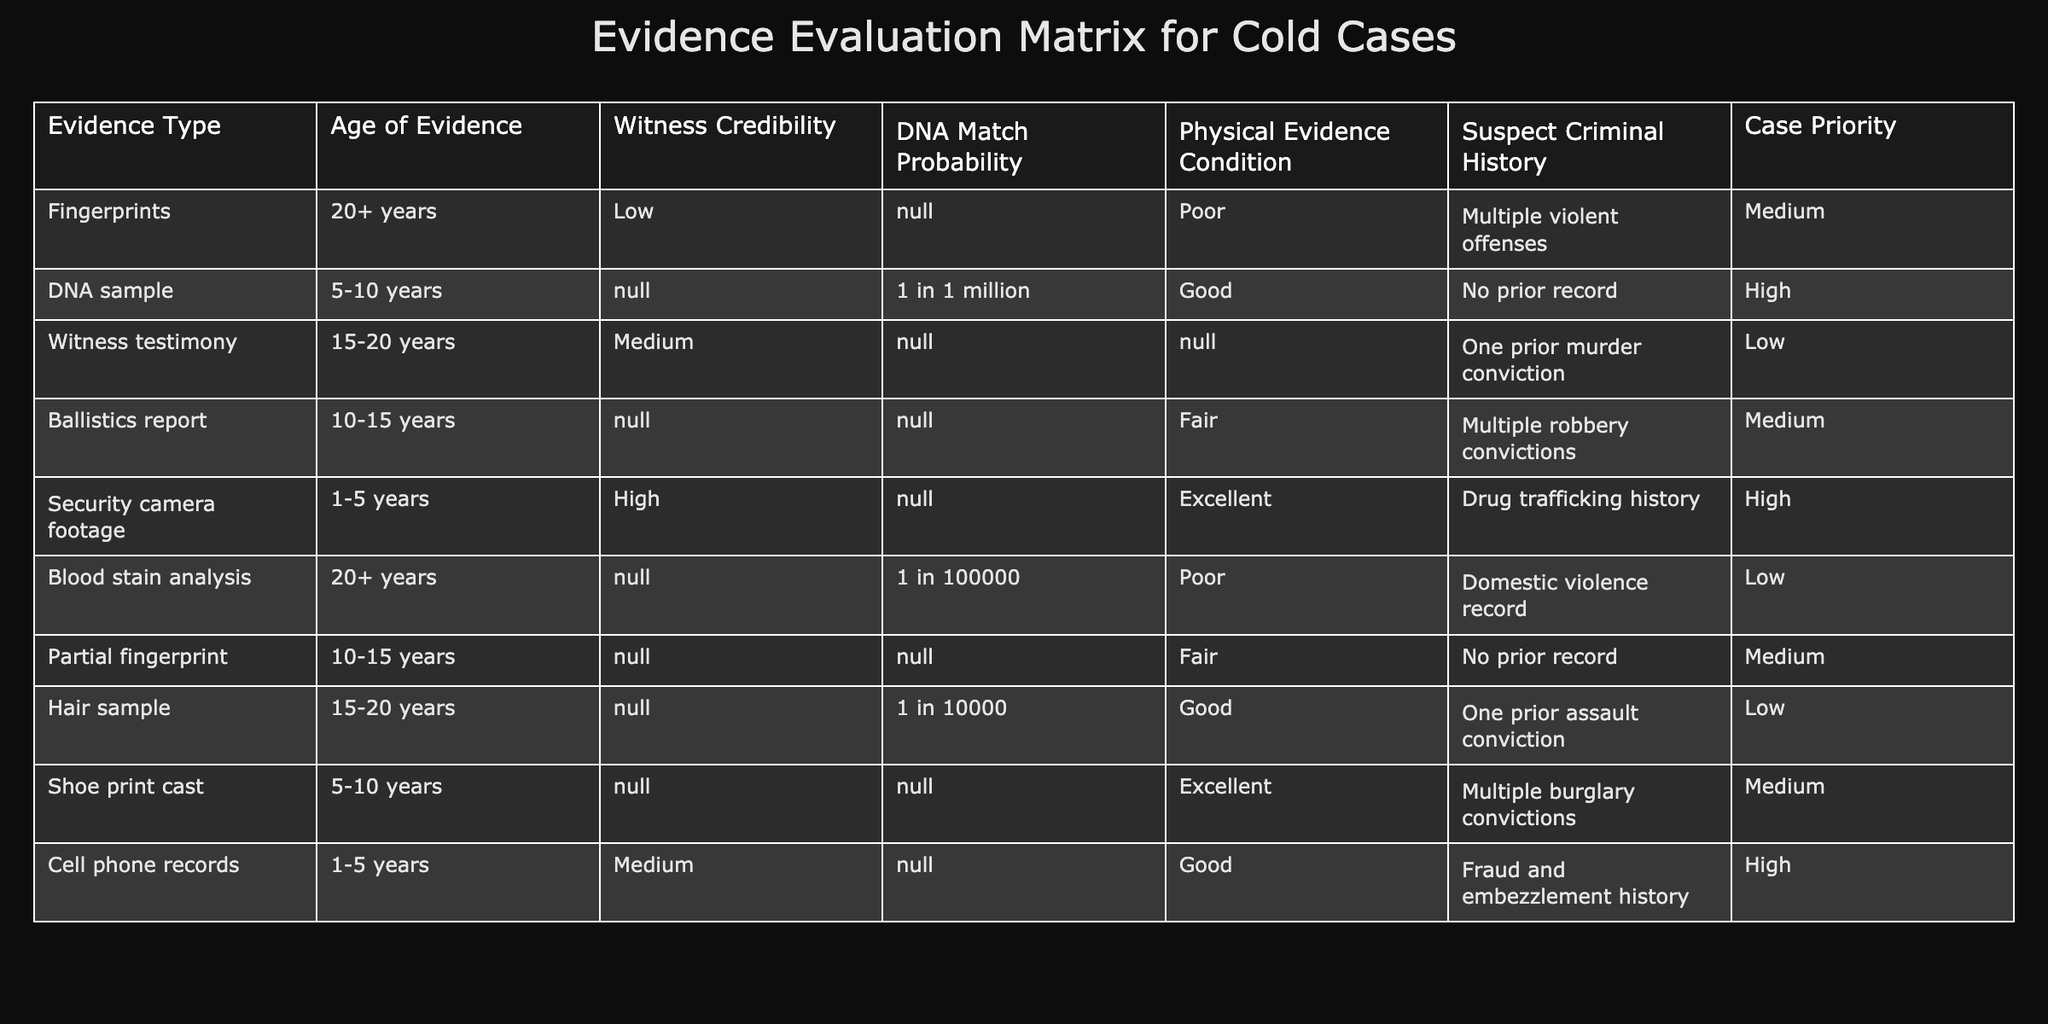What is the condition of the DNA sample evidence? From the table, the condition of the DNA sample evidence is listed under the "Physical Evidence Condition" column, which states "Good."
Answer: Good How many types of evidence have a "High" case priority? Scanning the table, there are three pieces of evidence that have a case priority of "High": DNA sample, security camera footage, and cell phone records.
Answer: 3 Is there any evidence type with both a "Poor" condition and a "Medium" case priority? Looking at the table, there is one type of evidence, fingerprints, that has a "Poor" condition and a "Medium" case priority. Therefore, the answer is yes.
Answer: Yes What type of evidence has the lowest witness credibility? By examining the "Witness Credibility" column, the evidence type with the lowest credibility is fingerprints, which is rated "Low."
Answer: Fingerprints How does the age of a DNA sample compare to that of a ballistics report? The age of the DNA sample is between 5-10 years, while the age of the ballistics report is between 10-15 years. Since 10-15 years is older than 5-10 years, the ballistics report is older.
Answer: Ballistics report is older Among the evidences listed, which type corresponds to a suspect with "No prior record" and what is the case priority associated with it? The only evidence with a suspect matching "No prior record" is the DNA sample, which has a case priority of "High."
Answer: DNA sample, High Calculate how many types of evidence have either “Medium” or “High” case priority. By counting the types with "Medium" and "High" from the “Case Priority” column, we find 5 types: Medium (fingerprints, ballistics report, partial fingerprint, shoe print cast) and High (DNA sample, security camera footage, cell phone records). Therefore, 5 types total.
Answer: 5 Is there any evidence type that has both a "Good" physical evidence condition and a "Low" case priority? Searching through the table, no evidence types exist that fulfill both conditions; thus, the answer is no.
Answer: No Which piece of evidence has the highest DNA match probability, and what is that probability? The DNA sample shows a DNA match probability of 1 in 1 million, which is the highest found in the table compared to any other evidence which shows a lesser or no probability.
Answer: DNA sample, 1 in 1 million 